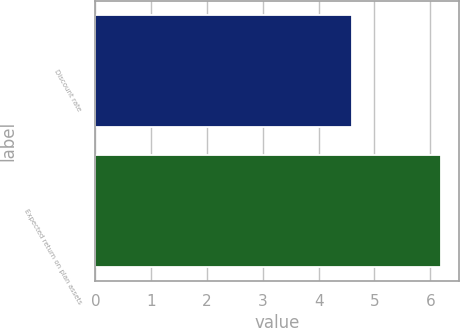<chart> <loc_0><loc_0><loc_500><loc_500><bar_chart><fcel>Discount rate<fcel>Expected return on plan assets<nl><fcel>4.6<fcel>6.2<nl></chart> 